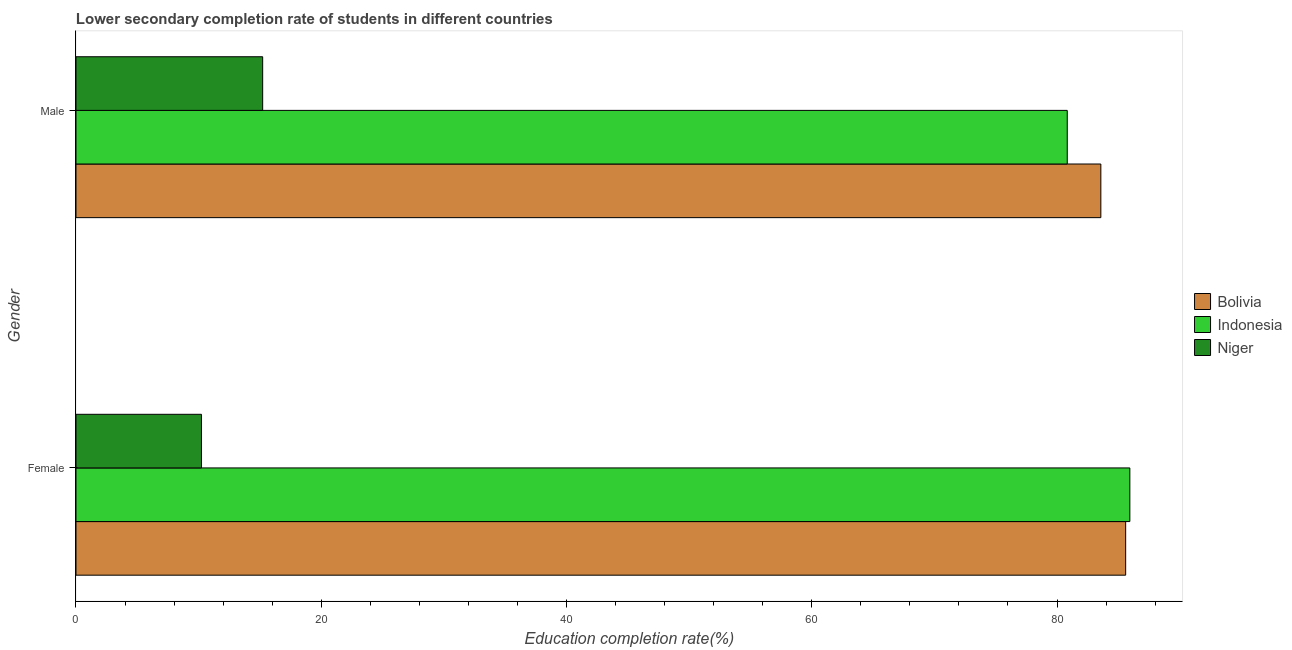Are the number of bars per tick equal to the number of legend labels?
Your answer should be compact. Yes. What is the label of the 2nd group of bars from the top?
Your answer should be compact. Female. What is the education completion rate of female students in Indonesia?
Give a very brief answer. 85.94. Across all countries, what is the maximum education completion rate of male students?
Ensure brevity in your answer.  83.57. Across all countries, what is the minimum education completion rate of female students?
Provide a short and direct response. 10.23. In which country was the education completion rate of male students minimum?
Your answer should be compact. Niger. What is the total education completion rate of male students in the graph?
Your answer should be compact. 179.63. What is the difference between the education completion rate of female students in Bolivia and that in Niger?
Keep it short and to the point. 75.37. What is the difference between the education completion rate of male students in Bolivia and the education completion rate of female students in Indonesia?
Offer a very short reply. -2.37. What is the average education completion rate of male students per country?
Your answer should be compact. 59.88. What is the difference between the education completion rate of female students and education completion rate of male students in Niger?
Offer a very short reply. -4.99. In how many countries, is the education completion rate of female students greater than 32 %?
Keep it short and to the point. 2. What is the ratio of the education completion rate of female students in Niger to that in Indonesia?
Your answer should be very brief. 0.12. In how many countries, is the education completion rate of female students greater than the average education completion rate of female students taken over all countries?
Ensure brevity in your answer.  2. What does the 1st bar from the top in Female represents?
Provide a succinct answer. Niger. How many bars are there?
Your response must be concise. 6. What is the difference between two consecutive major ticks on the X-axis?
Offer a very short reply. 20. Are the values on the major ticks of X-axis written in scientific E-notation?
Your answer should be compact. No. Does the graph contain any zero values?
Your answer should be very brief. No. Does the graph contain grids?
Keep it short and to the point. No. How many legend labels are there?
Provide a short and direct response. 3. How are the legend labels stacked?
Offer a very short reply. Vertical. What is the title of the graph?
Offer a very short reply. Lower secondary completion rate of students in different countries. What is the label or title of the X-axis?
Provide a succinct answer. Education completion rate(%). What is the label or title of the Y-axis?
Your response must be concise. Gender. What is the Education completion rate(%) of Bolivia in Female?
Your response must be concise. 85.6. What is the Education completion rate(%) in Indonesia in Female?
Offer a terse response. 85.94. What is the Education completion rate(%) in Niger in Female?
Make the answer very short. 10.23. What is the Education completion rate(%) in Bolivia in Male?
Your answer should be compact. 83.57. What is the Education completion rate(%) of Indonesia in Male?
Ensure brevity in your answer.  80.84. What is the Education completion rate(%) of Niger in Male?
Make the answer very short. 15.22. Across all Gender, what is the maximum Education completion rate(%) of Bolivia?
Keep it short and to the point. 85.6. Across all Gender, what is the maximum Education completion rate(%) of Indonesia?
Give a very brief answer. 85.94. Across all Gender, what is the maximum Education completion rate(%) of Niger?
Offer a very short reply. 15.22. Across all Gender, what is the minimum Education completion rate(%) in Bolivia?
Provide a succinct answer. 83.57. Across all Gender, what is the minimum Education completion rate(%) in Indonesia?
Your response must be concise. 80.84. Across all Gender, what is the minimum Education completion rate(%) in Niger?
Offer a terse response. 10.23. What is the total Education completion rate(%) of Bolivia in the graph?
Offer a terse response. 169.17. What is the total Education completion rate(%) in Indonesia in the graph?
Make the answer very short. 166.78. What is the total Education completion rate(%) of Niger in the graph?
Your response must be concise. 25.45. What is the difference between the Education completion rate(%) of Bolivia in Female and that in Male?
Provide a succinct answer. 2.02. What is the difference between the Education completion rate(%) in Indonesia in Female and that in Male?
Offer a terse response. 5.1. What is the difference between the Education completion rate(%) in Niger in Female and that in Male?
Your answer should be very brief. -4.99. What is the difference between the Education completion rate(%) of Bolivia in Female and the Education completion rate(%) of Indonesia in Male?
Ensure brevity in your answer.  4.76. What is the difference between the Education completion rate(%) of Bolivia in Female and the Education completion rate(%) of Niger in Male?
Provide a short and direct response. 70.37. What is the difference between the Education completion rate(%) in Indonesia in Female and the Education completion rate(%) in Niger in Male?
Make the answer very short. 70.72. What is the average Education completion rate(%) in Bolivia per Gender?
Make the answer very short. 84.59. What is the average Education completion rate(%) in Indonesia per Gender?
Keep it short and to the point. 83.39. What is the average Education completion rate(%) of Niger per Gender?
Give a very brief answer. 12.73. What is the difference between the Education completion rate(%) in Bolivia and Education completion rate(%) in Indonesia in Female?
Provide a short and direct response. -0.34. What is the difference between the Education completion rate(%) of Bolivia and Education completion rate(%) of Niger in Female?
Offer a very short reply. 75.37. What is the difference between the Education completion rate(%) in Indonesia and Education completion rate(%) in Niger in Female?
Your response must be concise. 75.71. What is the difference between the Education completion rate(%) in Bolivia and Education completion rate(%) in Indonesia in Male?
Offer a terse response. 2.74. What is the difference between the Education completion rate(%) in Bolivia and Education completion rate(%) in Niger in Male?
Your answer should be very brief. 68.35. What is the difference between the Education completion rate(%) of Indonesia and Education completion rate(%) of Niger in Male?
Offer a very short reply. 65.61. What is the ratio of the Education completion rate(%) of Bolivia in Female to that in Male?
Make the answer very short. 1.02. What is the ratio of the Education completion rate(%) of Indonesia in Female to that in Male?
Give a very brief answer. 1.06. What is the ratio of the Education completion rate(%) in Niger in Female to that in Male?
Give a very brief answer. 0.67. What is the difference between the highest and the second highest Education completion rate(%) of Bolivia?
Keep it short and to the point. 2.02. What is the difference between the highest and the second highest Education completion rate(%) in Indonesia?
Provide a succinct answer. 5.1. What is the difference between the highest and the second highest Education completion rate(%) in Niger?
Make the answer very short. 4.99. What is the difference between the highest and the lowest Education completion rate(%) of Bolivia?
Make the answer very short. 2.02. What is the difference between the highest and the lowest Education completion rate(%) in Indonesia?
Provide a short and direct response. 5.1. What is the difference between the highest and the lowest Education completion rate(%) in Niger?
Your answer should be compact. 4.99. 